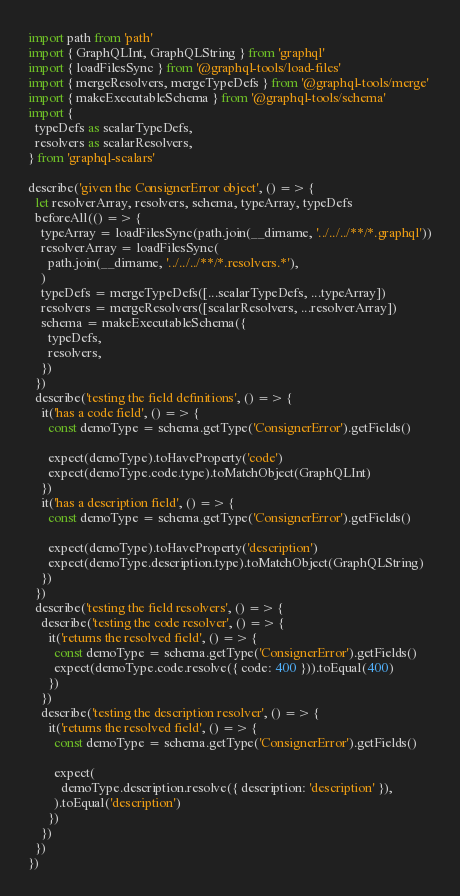<code> <loc_0><loc_0><loc_500><loc_500><_JavaScript_>import path from 'path'
import { GraphQLInt, GraphQLString } from 'graphql'
import { loadFilesSync } from '@graphql-tools/load-files'
import { mergeResolvers, mergeTypeDefs } from '@graphql-tools/merge'
import { makeExecutableSchema } from '@graphql-tools/schema'
import {
  typeDefs as scalarTypeDefs,
  resolvers as scalarResolvers,
} from 'graphql-scalars'

describe('given the ConsignerError object', () => {
  let resolverArray, resolvers, schema, typeArray, typeDefs
  beforeAll(() => {
    typeArray = loadFilesSync(path.join(__dirname, '../../../**/*.graphql'))
    resolverArray = loadFilesSync(
      path.join(__dirname, '../../../**/*.resolvers.*'),
    )
    typeDefs = mergeTypeDefs([...scalarTypeDefs, ...typeArray])
    resolvers = mergeResolvers([scalarResolvers, ...resolverArray])
    schema = makeExecutableSchema({
      typeDefs,
      resolvers,
    })
  })
  describe('testing the field definitions', () => {
    it('has a code field', () => {
      const demoType = schema.getType('ConsignerError').getFields()

      expect(demoType).toHaveProperty('code')
      expect(demoType.code.type).toMatchObject(GraphQLInt)
    })
    it('has a description field', () => {
      const demoType = schema.getType('ConsignerError').getFields()

      expect(demoType).toHaveProperty('description')
      expect(demoType.description.type).toMatchObject(GraphQLString)
    })
  })
  describe('testing the field resolvers', () => {
    describe('testing the code resolver', () => {
      it('returns the resolved field', () => {
        const demoType = schema.getType('ConsignerError').getFields()
        expect(demoType.code.resolve({ code: 400 })).toEqual(400)
      })
    })
    describe('testing the description resolver', () => {
      it('returns the resolved field', () => {
        const demoType = schema.getType('ConsignerError').getFields()

        expect(
          demoType.description.resolve({ description: 'description' }),
        ).toEqual('description')
      })
    })
  })
})
</code> 